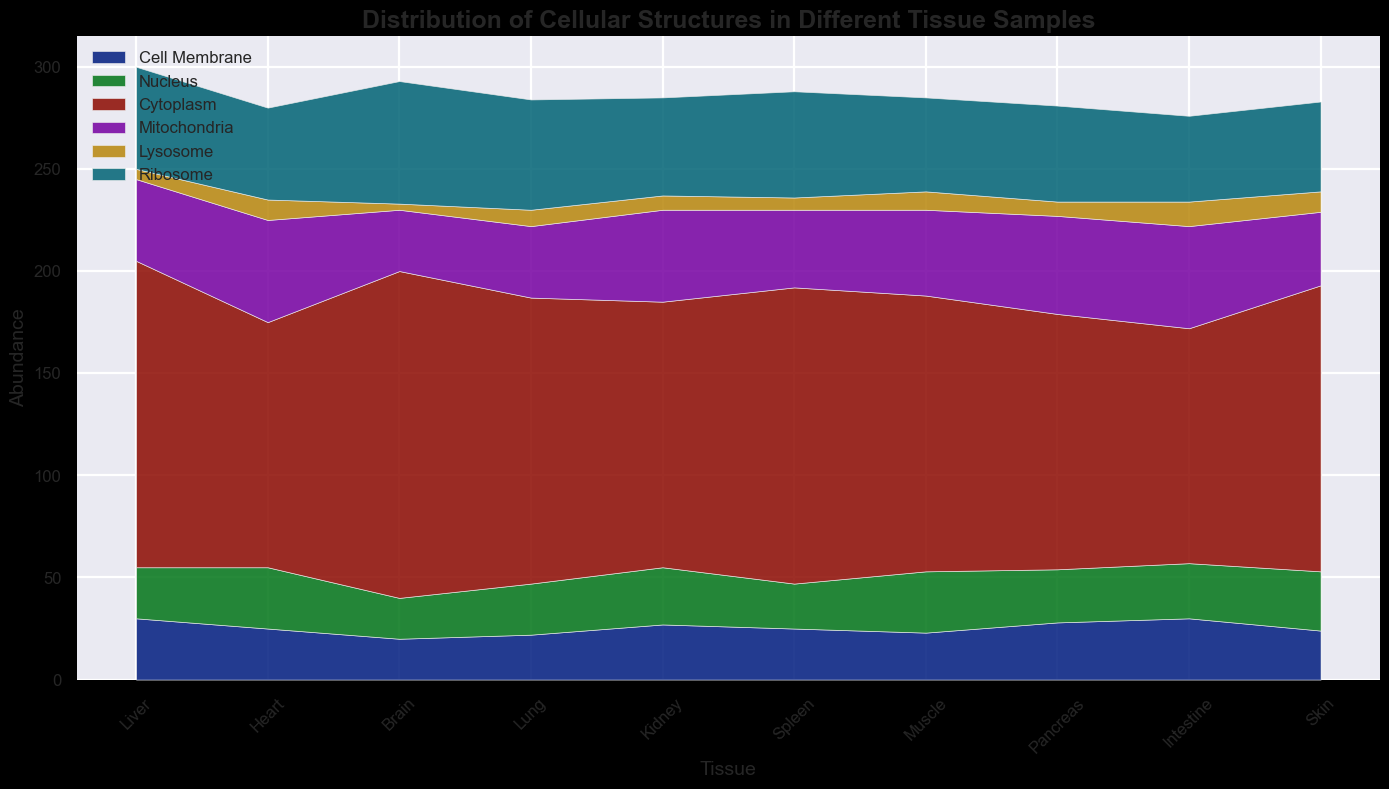Which tissue has the highest abundance of mitochondria? To find the tissue with the highest abundance of mitochondria, look for the peak value in the section representing mitochondria. According to the plot, the tissue with the highest abundance of mitochondria is the Intestine with 50 units.
Answer: Intestine Which tissue has the lowest overall abundance of cellular structures? To determine which tissue has the lowest overall abundance of cellular structures, add up the values for all structures in each tissue and compare. The Brain tissue has the lowest overall abundance (20+20+160+30+3+60=293).
Answer: Brain Which cellular structure is the most abundant in Brain tissue? Look at the Brain section and identify the tallest segment. The tallest segment represents the Cytoplasm.
Answer: Cytoplasm How does the abundance of the Nucleus compare between Liver and Heart tissues? Find the segments representing the Nucleus in both Liver and Heart tissues and compare their heights. Liver has 25 units, and Heart has 30 units, so Heart has a higher abundance.
Answer: Heart What is the difference in Ribosome abundance between Lung and Kidney tissues? Look for the segments representing the Ribosome in both Lung and Kidney tissues and subtract the values. Lung has 54 units, and Kidney has 48 units, so the difference is 54 - 48 = 6 units.
Answer: 6 What is the combined abundance of Cell Membrane and Lysosome in Spleen tissue? Add the values of Cell Membrane (25) and Lysosome (6) in the Spleen tissue. 25 + 6 = 31
Answer: 31 Which tissue has more Cell Membrane, Pancreas or Skin? Compare the segments representing the Cell Membrane in Pancreas and Skin tissues. Pancreas has 28 units, and Skin has 24 units, so Pancreas has more.
Answer: Pancreas Is the abundance of the Mitochondria higher in Muscle or Liver tissue? Compare the heights of the Mitochondria segments in Muscle and Liver tissues. Muscle has 42 units, whereas Liver has 40 units, so Muscle has a higher abundance.
Answer: Muscle What is the ratio of Cytoplasm abundance between Liver and Intestine tissues? Divide the abundance of Cytoplasm in Liver (150) by that in Intestine (115). The ratio is 150/115, approximately 1.3.
Answer: 1.3 Which tissue has an equal abundance of Nucleus and Mitochondria? Identify the tissue where the segments representing Nucleus and Mitochondria have the same height. In Intestine, both Nucleus and Mitochondria are 27 and 50 units, respectively. This does not have any equal ratio, thus review the data properly. Upon reviewing none there are no equal values for Nucleus and Mitochondria but only one is close enough as Pancreas with 26 and 48 units.
Answer: None 